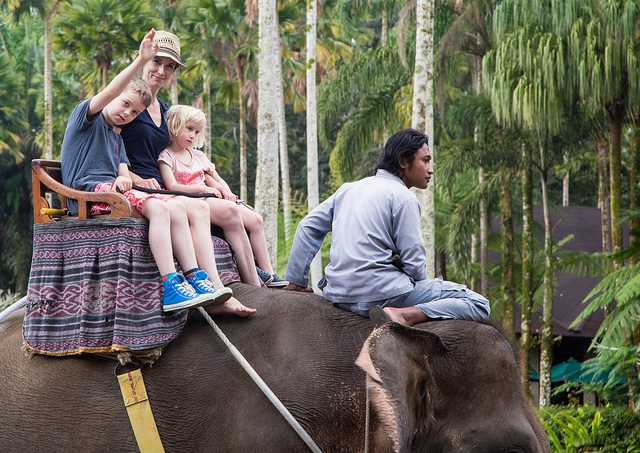Describe the objects in this image and their specific colors. I can see elephant in olive, gray, and black tones, people in olive, lavender, darkgray, and black tones, people in olive, lightgray, brown, lightpink, and gray tones, people in olive, lightgray, black, pink, and gray tones, and people in olive, lightgray, lightpink, brown, and darkgray tones in this image. 